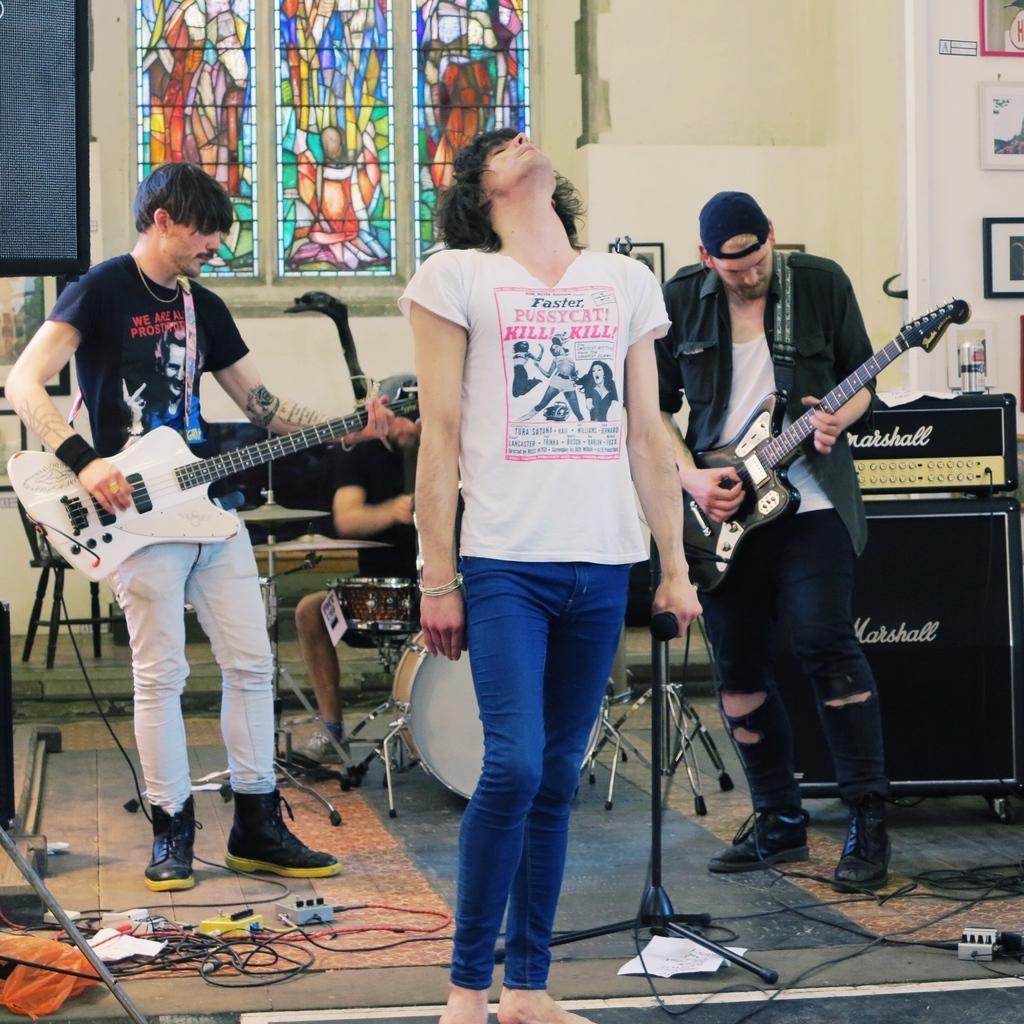How would you summarize this image in a sentence or two? In this image the person is holding a mic. At the back side three person are playing a musical instruments. 